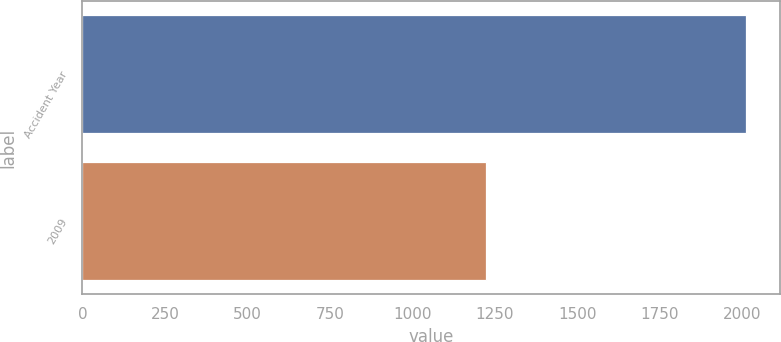<chart> <loc_0><loc_0><loc_500><loc_500><bar_chart><fcel>Accident Year<fcel>2009<nl><fcel>2013<fcel>1223<nl></chart> 